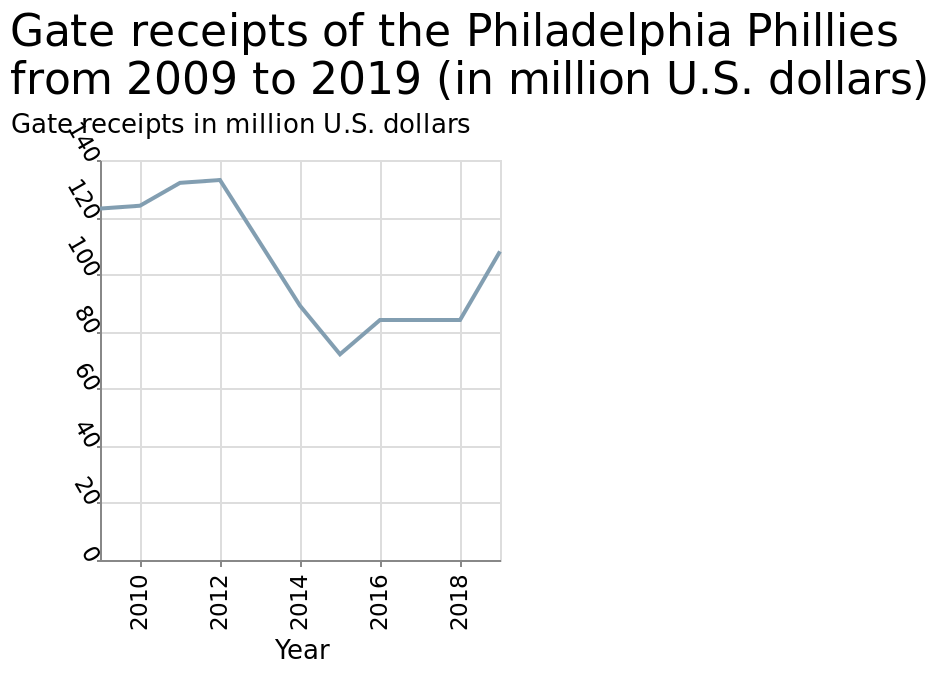<image>
What does the y-axis of the line chart represent? The y-axis represents the gate receipts in million U.S. dollars. Did the gate receipts remain the same for the Philadelphia Phillies between 2016 and 2018?  Yes, the gate receipts were kept the same between 2016 and 2018 for the Philadelphia Phillies. please describe the details of the chart Gate receipts of the Philadelphia Phillies from 2009 to 2019 (in million U.S. dollars) is a line chart. On the x-axis, Year is plotted using a linear scale with a minimum of 2010 and a maximum of 2018. A linear scale from 0 to 140 can be found on the y-axis, marked Gate receipts in million U.S. dollars. 